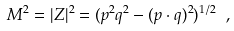<formula> <loc_0><loc_0><loc_500><loc_500>M ^ { 2 } = | Z | ^ { 2 } = ( p ^ { 2 } q ^ { 2 } - ( p \cdot q ) ^ { 2 } ) ^ { 1 / 2 } \ ,</formula> 